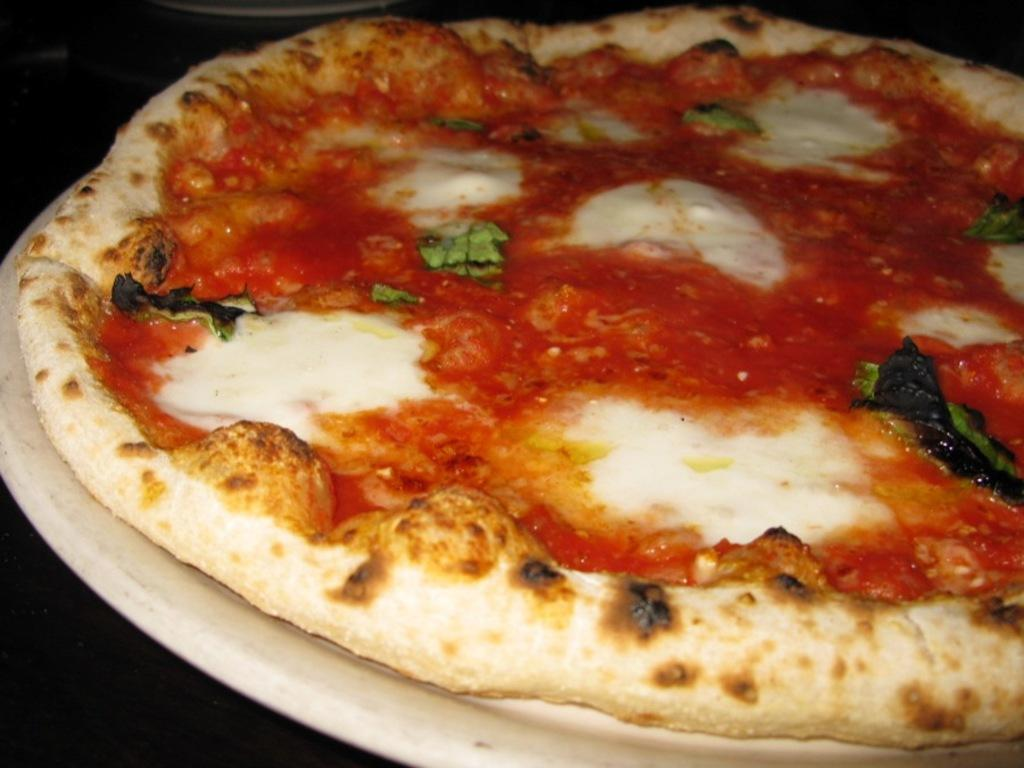What is on the plate that is visible in the image? There is food on a plate in the image. What color is the plate? The plate is white. What type of bell can be heard ringing in the image? There is no bell present in the image, and therefore no sound can be heard. 